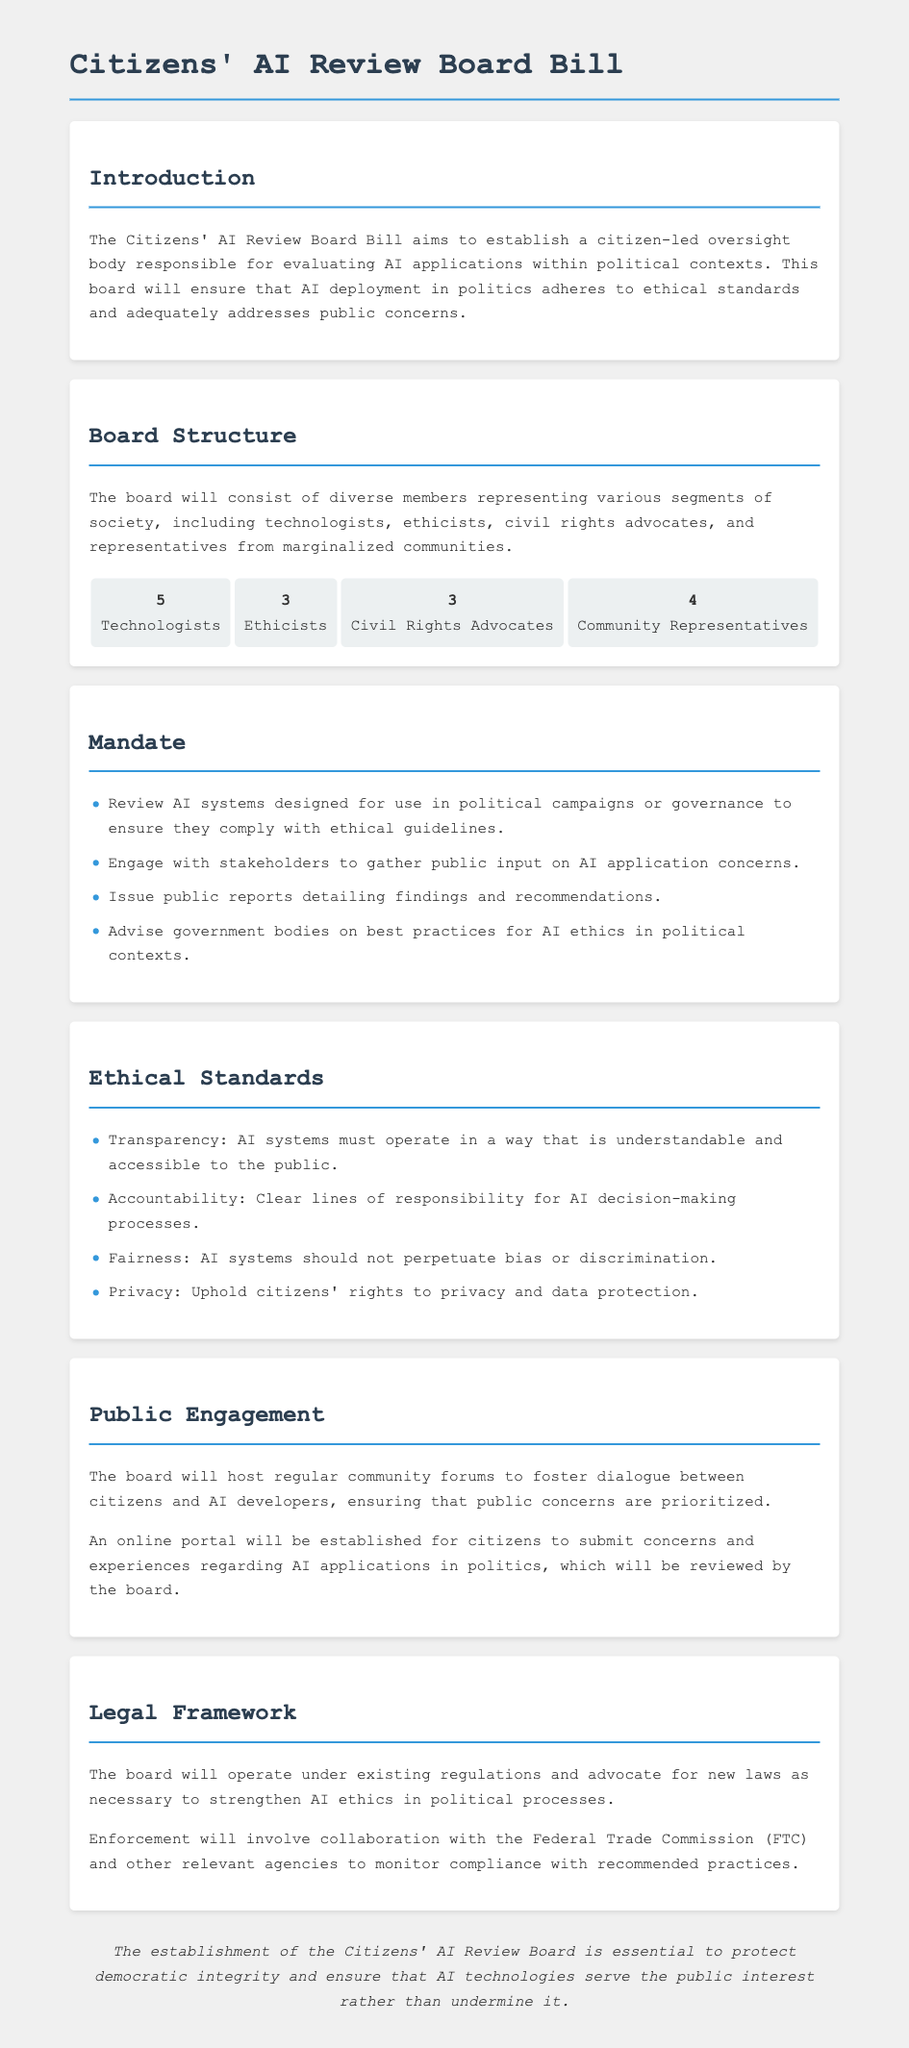What is the main purpose of the bill? The main purpose of the bill is to establish a citizen-led oversight body responsible for evaluating AI applications within political contexts.
Answer: Establish a citizen-led oversight body How many technologists are on the board? The board composition specifies the number of technologists included, which is five.
Answer: 5 What are the first two ethical standards listed? The first two ethical standards listed are transparency and accountability.
Answer: Transparency, Accountability Which organization will collaborate to monitor compliance? The enforcement of the board's recommendations will involve collaboration with the Federal Trade Commission, as mentioned in the legal framework section.
Answer: Federal Trade Commission How many community representatives are on the board? The board composition includes four members representing community representatives.
Answer: 4 What method will the board use to gather public input? The board will engage with stakeholders and host community forums to gather input, as noted in the public engagement section.
Answer: Community forums What is one of the board's mandates? One of the mandates is to issue public reports detailing findings and recommendations.
Answer: Issue public reports How will citizens submit their concerns? Citizens will be able to submit concerns through an online portal established by the board.
Answer: Online portal 